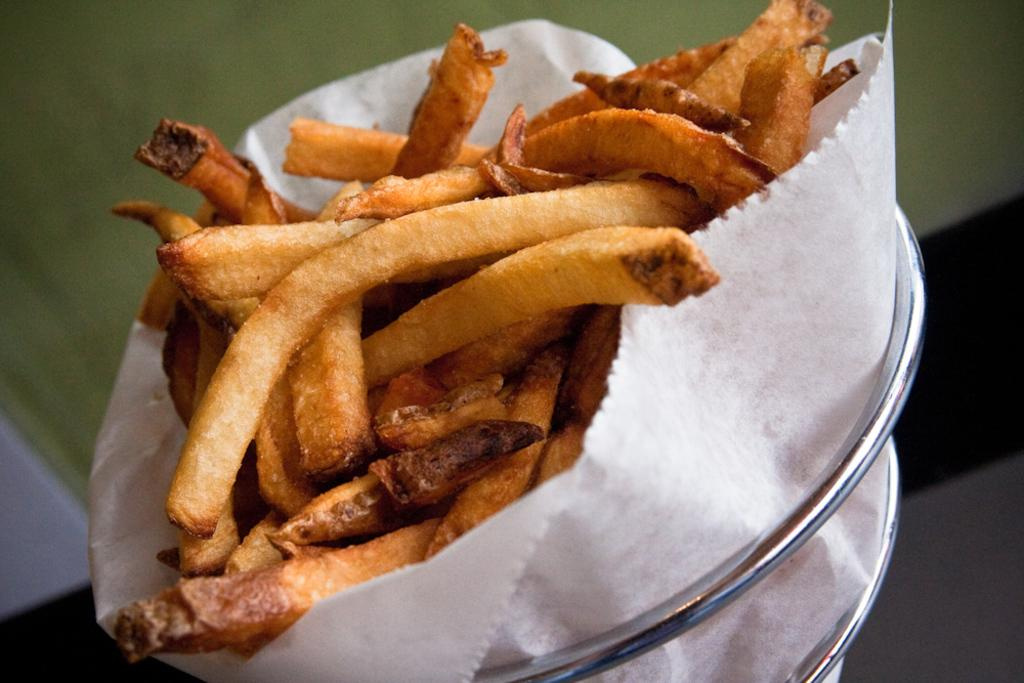What type of food is in the bowl in the image? There are fried snacks in a bowl in the image. What is located next to the bowl? There is a tissue next to the bowl. What can be seen in the background of the image? There is a wall visible in the background of the image. What type of spade is being used at the event in the image? There is no spade or event present in the image. How does the person's knee look in the image? There is no person or knee visible in the image. 